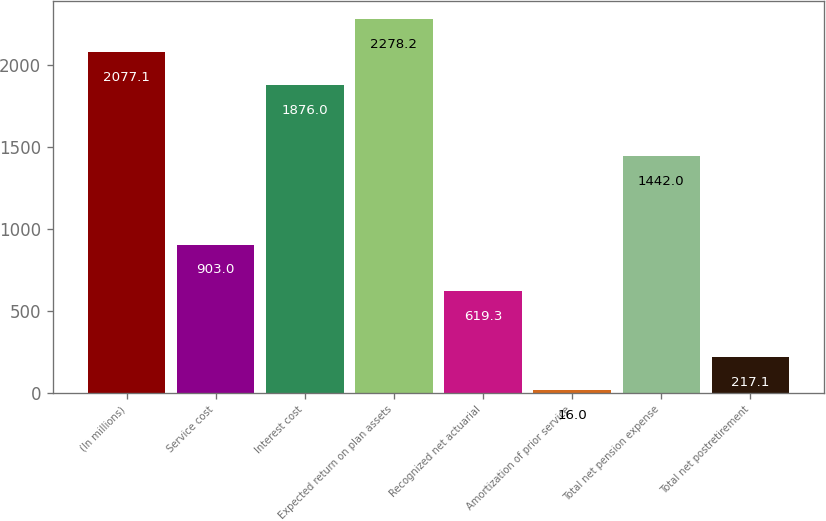Convert chart. <chart><loc_0><loc_0><loc_500><loc_500><bar_chart><fcel>(In millions)<fcel>Service cost<fcel>Interest cost<fcel>Expected return on plan assets<fcel>Recognized net actuarial<fcel>Amortization of prior service<fcel>Total net pension expense<fcel>Total net postretirement<nl><fcel>2077.1<fcel>903<fcel>1876<fcel>2278.2<fcel>619.3<fcel>16<fcel>1442<fcel>217.1<nl></chart> 